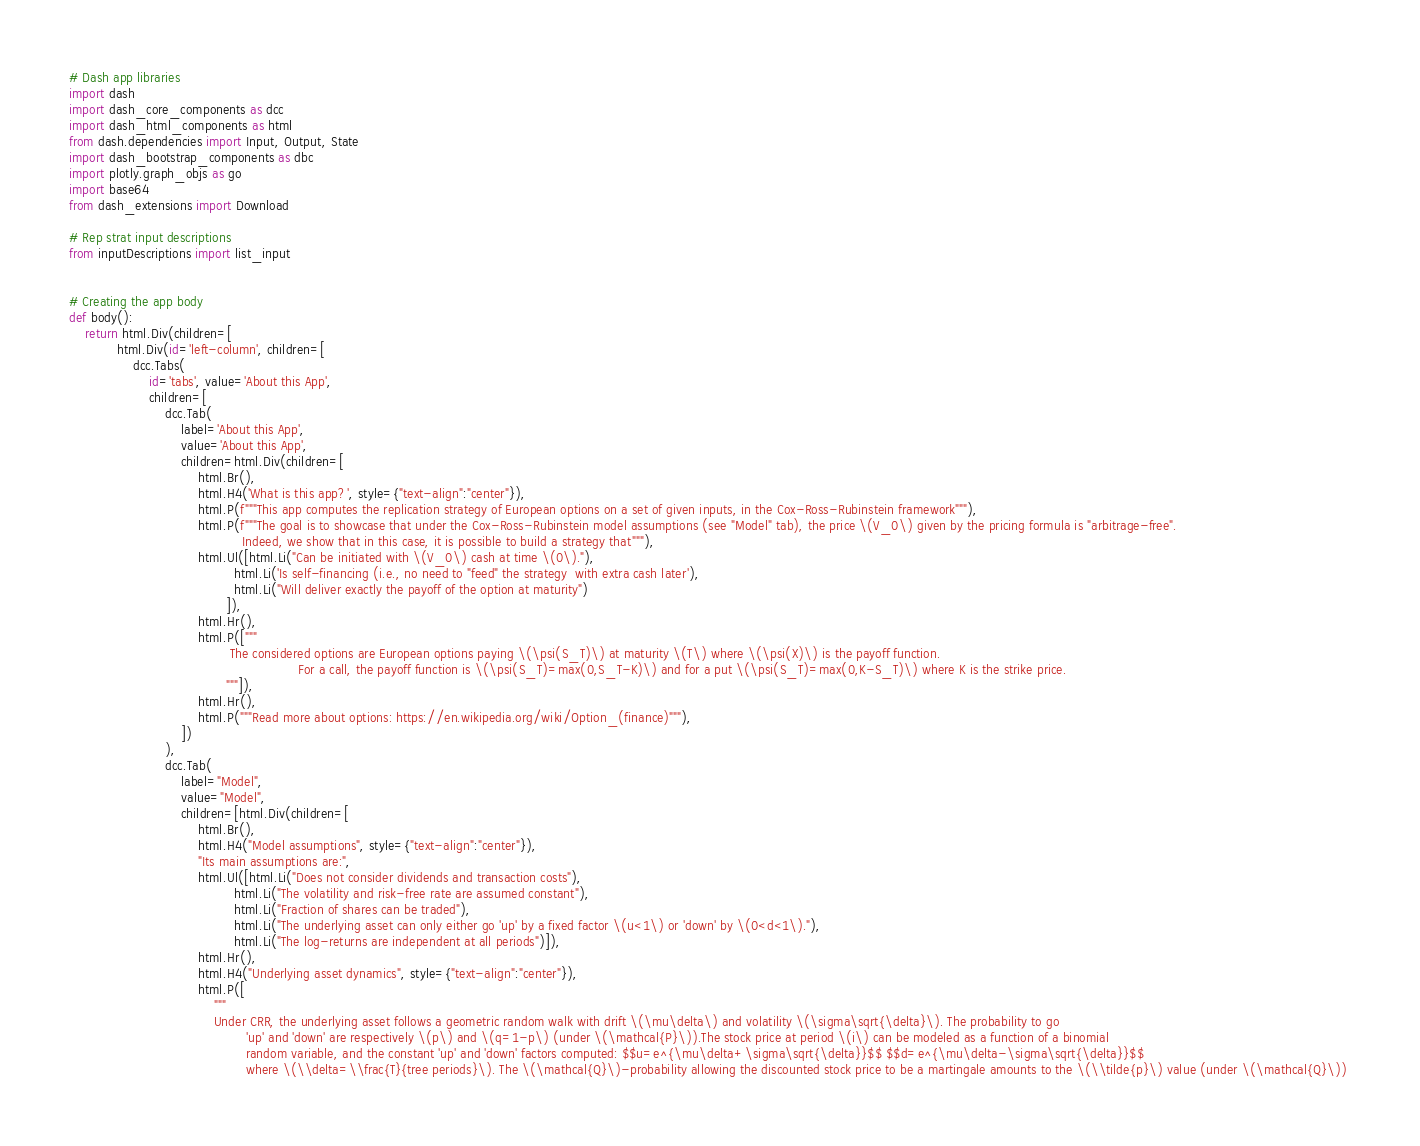<code> <loc_0><loc_0><loc_500><loc_500><_Python_># Dash app libraries
import dash
import dash_core_components as dcc
import dash_html_components as html
from dash.dependencies import Input, Output, State
import dash_bootstrap_components as dbc
import plotly.graph_objs as go
import base64
from dash_extensions import Download

# Rep strat input descriptions
from inputDescriptions import list_input


# Creating the app body
def body():
    return html.Div(children=[
            html.Div(id='left-column', children=[
                dcc.Tabs(
                    id='tabs', value='About this App',
                    children=[
                        dcc.Tab(
                            label='About this App',
                            value='About this App',
                            children=html.Div(children=[
                                html.Br(),
                                html.H4('What is this app?', style={"text-align":"center"}),
                                html.P(f"""This app computes the replication strategy of European options on a set of given inputs, in the Cox-Ross-Rubinstein framework"""),
                                html.P(f"""The goal is to showcase that under the Cox-Ross-Rubinstein model assumptions (see "Model" tab), the price \(V_0\) given by the pricing formula is "arbitrage-free". 
                                           Indeed, we show that in this case, it is possible to build a strategy that"""),
                                html.Ul([html.Li("Can be initiated with \(V_0\) cash at time \(0\)."), 
                                         html.Li('Is self-financing (i.e., no need to "feed" the strategy  with extra cash later'),
                                         html.Li("Will deliver exactly the payoff of the option at maturity")
                                       ]),
                                html.Hr(),
                                html.P(["""
                                	    The considered options are European options paying \(\psi(S_T)\) at maturity \(T\) where \(\psi(X)\) is the payoff function. 
						   				                 For a call, the payoff function is \(\psi(S_T)=max(0,S_T-K)\) and for a put \(\psi(S_T)=max(0,K-S_T)\) where K is the strike price.
                                       """]),
                                html.Hr(),
                                html.P("""Read more about options: https://en.wikipedia.org/wiki/Option_(finance)"""),
                            ])
                        ),
                        dcc.Tab(
                            label="Model",
                            value="Model",
                            children=[html.Div(children=[
                                html.Br(),
                                html.H4("Model assumptions", style={"text-align":"center"}),
                                "Its main assumptions are:",
                                html.Ul([html.Li("Does not consider dividends and transaction costs"), 
                                         html.Li("The volatility and risk-free rate are assumed constant"),
                                         html.Li("Fraction of shares can be traded"),
                                         html.Li("The underlying asset can only either go 'up' by a fixed factor \(u<1\) or 'down' by \(0<d<1\)."),
                                         html.Li("The log-returns are independent at all periods")]),
                                html.Hr(),
                                html.H4("Underlying asset dynamics", style={"text-align":"center"}),
                                html.P([
                                    """
                                    Under CRR, the underlying asset follows a geometric random walk with drift \(\mu\delta\) and volatility \(\sigma\sqrt{\delta}\). The probability to go 
                          					'up' and 'down' are respectively \(p\) and \(q=1-p\) (under \(\mathcal{P}\)).The stock price at period \(i\) can be modeled as a function of a binomial 
                          					random variable, and the constant 'up' and 'down' factors computed: $$u=e^{\mu\delta+\sigma\sqrt{\delta}}$$ $$d=e^{\mu\delta-\sigma\sqrt{\delta}}$$ 
                          					where \(\\delta=\\frac{T}{tree periods}\). The \(\mathcal{Q}\)-probability allowing the discounted stock price to be a martingale amounts to the \(\\tilde{p}\) value (under \(\mathcal{Q}\)) </code> 